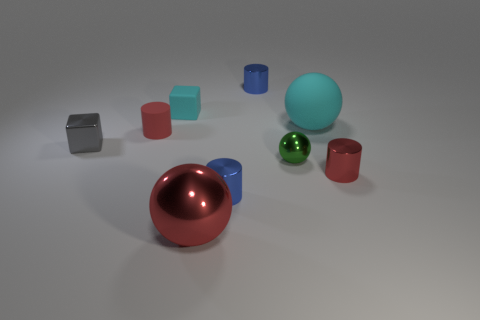Subtract 1 cylinders. How many cylinders are left? 3 Add 1 big cyan balls. How many objects exist? 10 Subtract all balls. How many objects are left? 6 Subtract 0 brown balls. How many objects are left? 9 Subtract all small cubes. Subtract all tiny red things. How many objects are left? 5 Add 6 big red things. How many big red things are left? 7 Add 4 small blue cylinders. How many small blue cylinders exist? 6 